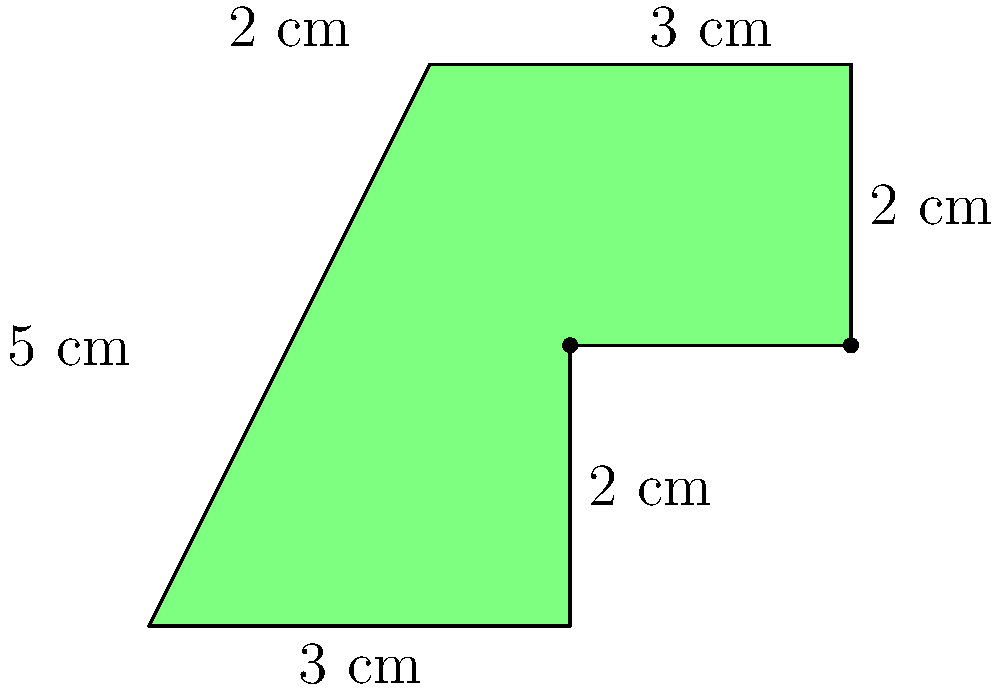A curious cat stumbles upon an irregularly shaped catnip toy. The toy is made up of a rectangle and a square connected together. If the dimensions are as shown in the diagram, what is the total area of the catnip toy in square centimeters? To find the total area of the irregularly shaped catnip toy, we need to break it down into two parts: a rectangle and a square. Then, we'll calculate their areas separately and add them together.

1. Area of the rectangle:
   Length = 3 cm
   Width = 4 cm
   Area of rectangle = $3 \times 4 = 12$ cm²

2. Area of the square:
   Side length = 2 cm
   Area of square = $2 \times 2 = 4$ cm²

3. Total area:
   Total area = Area of rectangle + Area of square
               = $12 + 4 = 16$ cm²

Therefore, the total area of the catnip toy is 16 square centimeters.
Answer: 16 cm² 